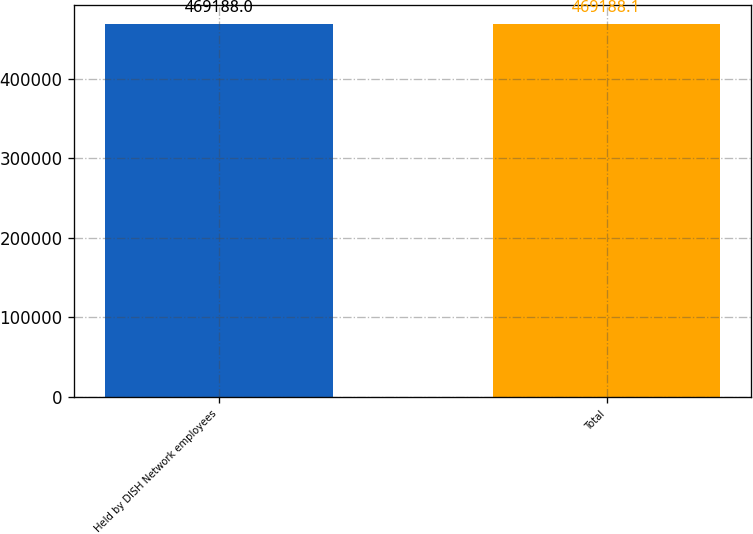<chart> <loc_0><loc_0><loc_500><loc_500><bar_chart><fcel>Held by DISH Network employees<fcel>Total<nl><fcel>469188<fcel>469188<nl></chart> 